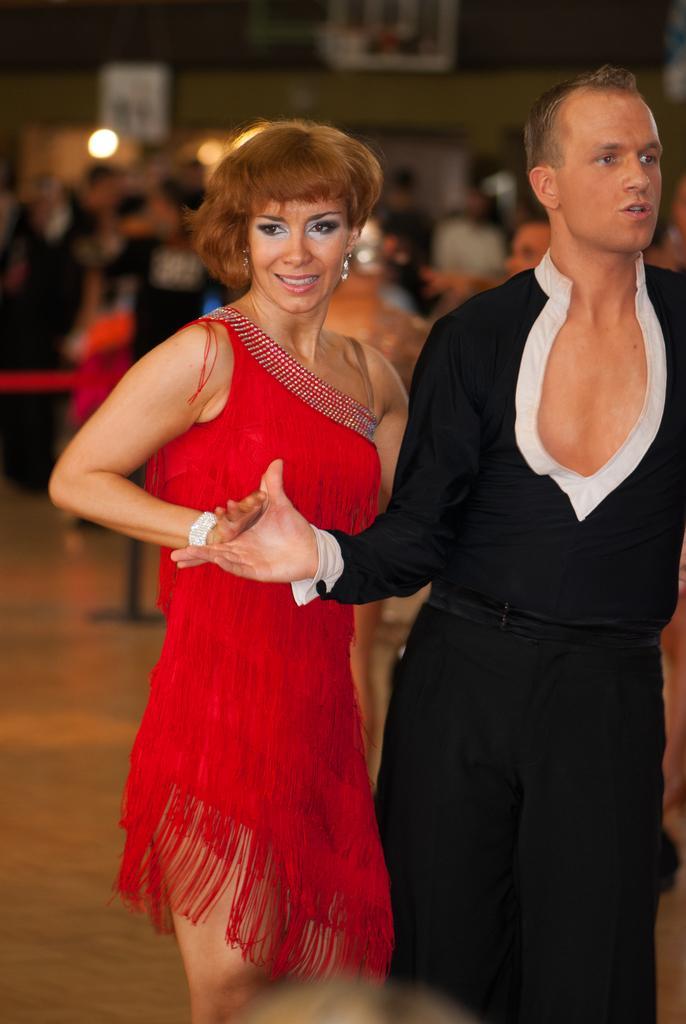Can you describe this image briefly? In this image I can see 2 people standing at the front. The woman at the center is wearing a red dress and the person on the right is wearing a black dress. The background is blurred. 